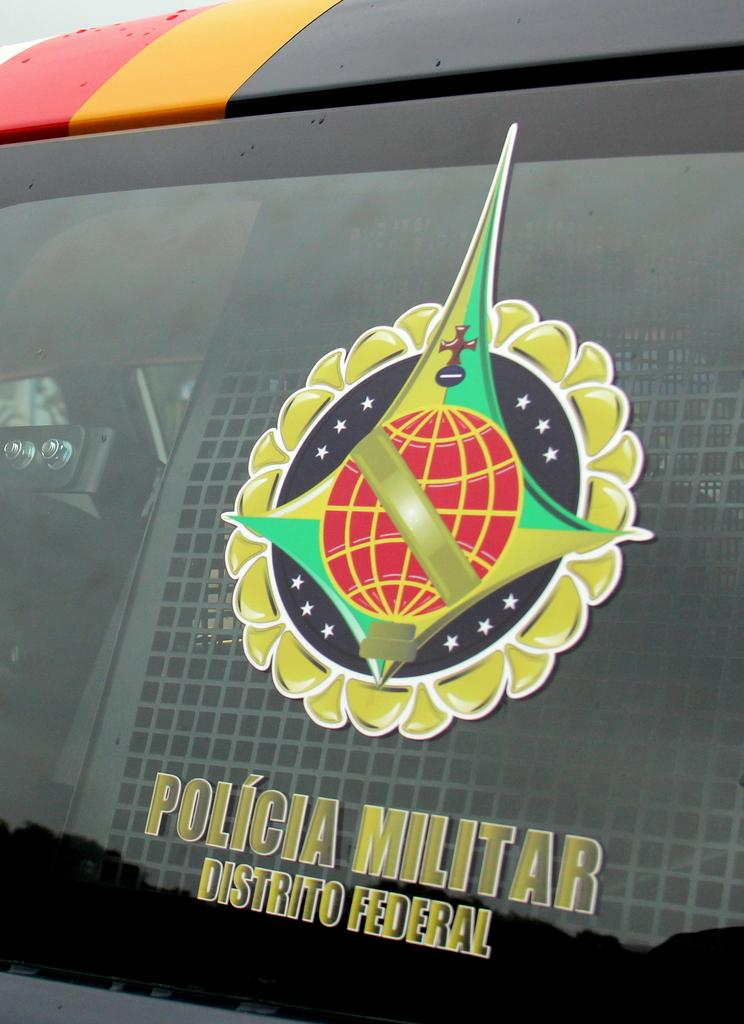<image>
Create a compact narrative representing the image presented. The symbol for the Policia Militar Distrito Federal includes a red globe. 